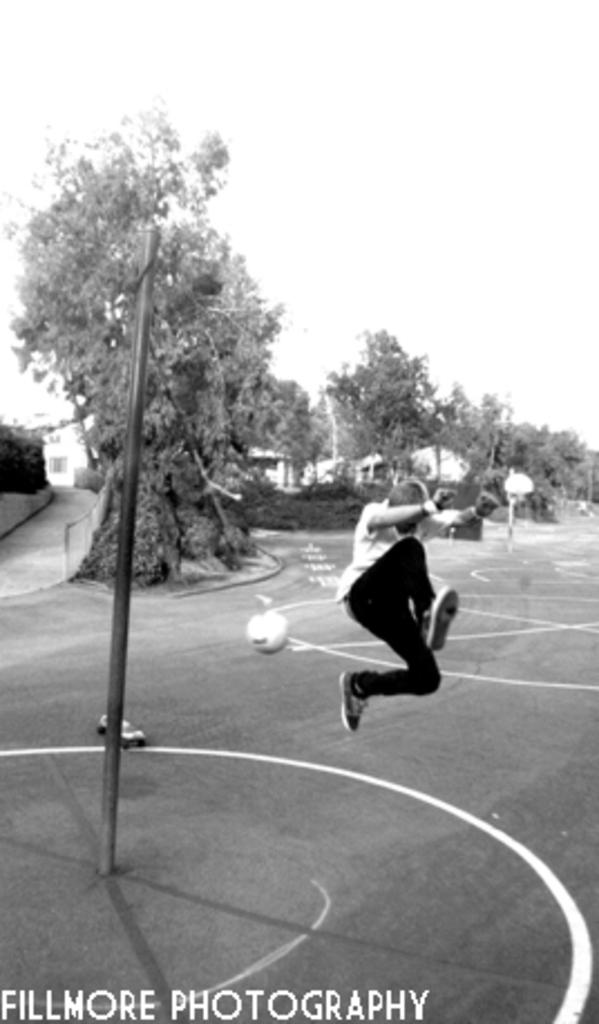What is located in the front of the image? There is a pole in the front of the image. What is the person in the image doing? There is a person jumping in the air. What is also present in the air? A ball is present in the air. What can be seen in the background of the image? There are trees and buildings in the background of the image. What flavor of medicine is the doctor prescribing to the father in the image? There is no doctor or father present in the image, and therefore no such interaction can be observed. 